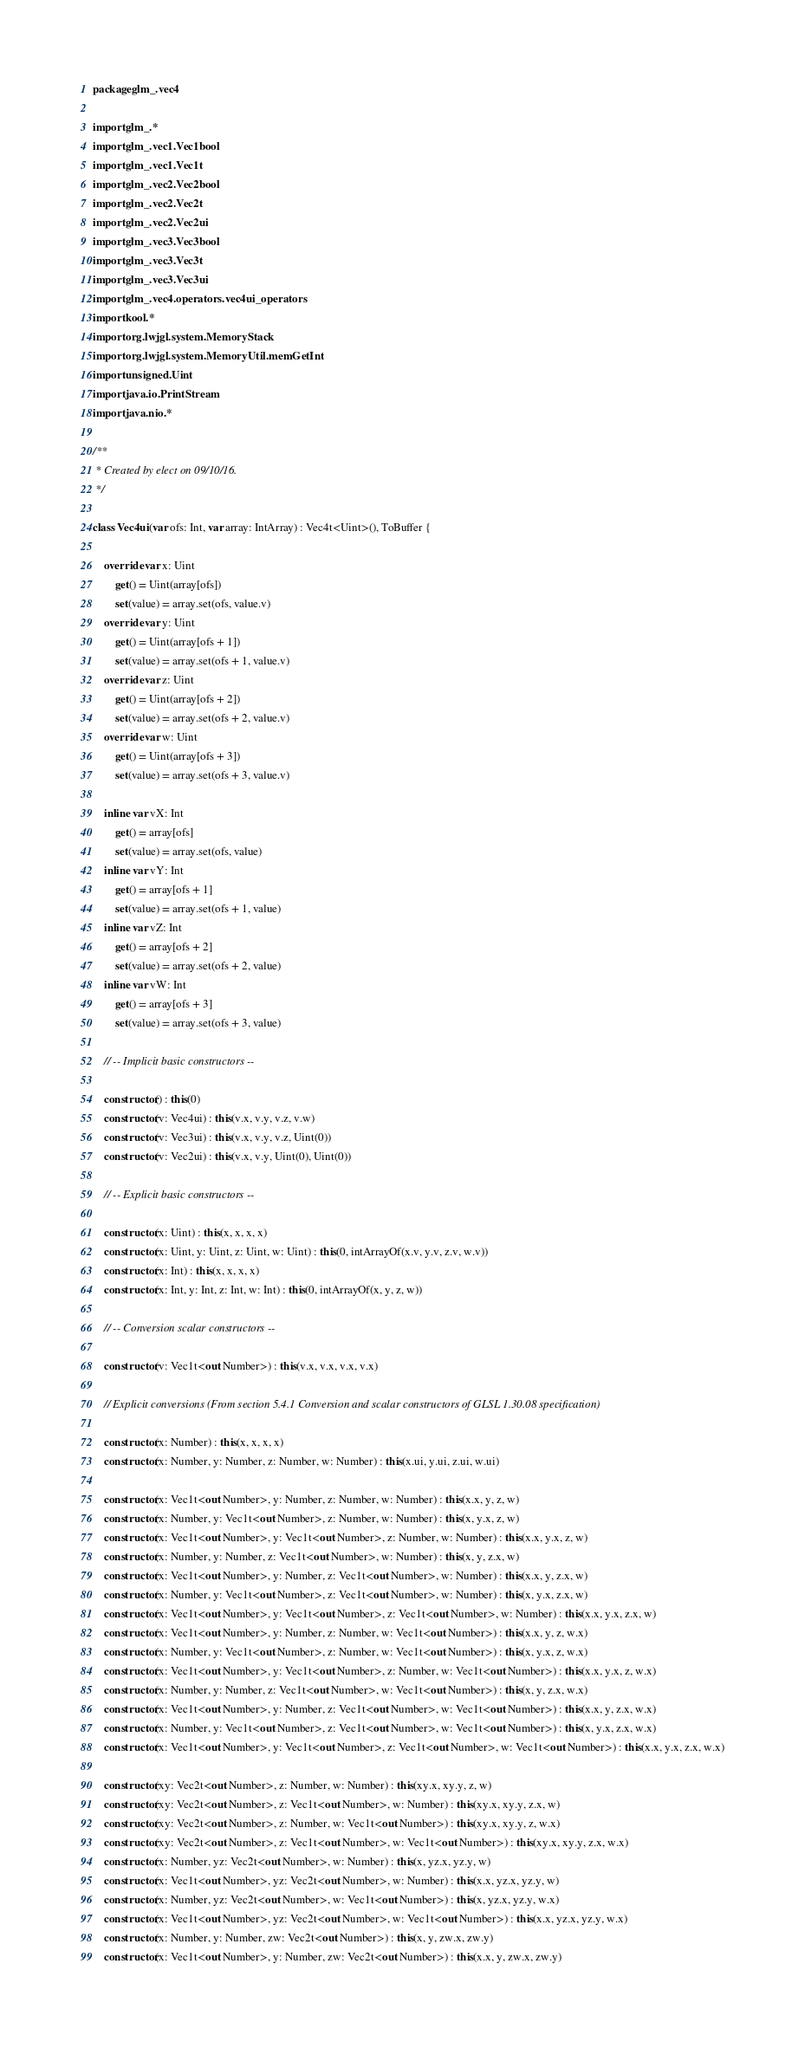Convert code to text. <code><loc_0><loc_0><loc_500><loc_500><_Kotlin_>package glm_.vec4

import glm_.*
import glm_.vec1.Vec1bool
import glm_.vec1.Vec1t
import glm_.vec2.Vec2bool
import glm_.vec2.Vec2t
import glm_.vec2.Vec2ui
import glm_.vec3.Vec3bool
import glm_.vec3.Vec3t
import glm_.vec3.Vec3ui
import glm_.vec4.operators.vec4ui_operators
import kool.*
import org.lwjgl.system.MemoryStack
import org.lwjgl.system.MemoryUtil.memGetInt
import unsigned.Uint
import java.io.PrintStream
import java.nio.*

/**
 * Created by elect on 09/10/16.
 */

class Vec4ui(var ofs: Int, var array: IntArray) : Vec4t<Uint>(), ToBuffer {

    override var x: Uint
        get() = Uint(array[ofs])
        set(value) = array.set(ofs, value.v)
    override var y: Uint
        get() = Uint(array[ofs + 1])
        set(value) = array.set(ofs + 1, value.v)
    override var z: Uint
        get() = Uint(array[ofs + 2])
        set(value) = array.set(ofs + 2, value.v)
    override var w: Uint
        get() = Uint(array[ofs + 3])
        set(value) = array.set(ofs + 3, value.v)

    inline var vX: Int
        get() = array[ofs]
        set(value) = array.set(ofs, value)
    inline var vY: Int
        get() = array[ofs + 1]
        set(value) = array.set(ofs + 1, value)
    inline var vZ: Int
        get() = array[ofs + 2]
        set(value) = array.set(ofs + 2, value)
    inline var vW: Int
        get() = array[ofs + 3]
        set(value) = array.set(ofs + 3, value)

    // -- Implicit basic constructors --

    constructor() : this(0)
    constructor(v: Vec4ui) : this(v.x, v.y, v.z, v.w)
    constructor(v: Vec3ui) : this(v.x, v.y, v.z, Uint(0))
    constructor(v: Vec2ui) : this(v.x, v.y, Uint(0), Uint(0))

    // -- Explicit basic constructors --

    constructor(x: Uint) : this(x, x, x, x)
    constructor(x: Uint, y: Uint, z: Uint, w: Uint) : this(0, intArrayOf(x.v, y.v, z.v, w.v))
    constructor(x: Int) : this(x, x, x, x)
    constructor(x: Int, y: Int, z: Int, w: Int) : this(0, intArrayOf(x, y, z, w))

    // -- Conversion scalar constructors --

    constructor(v: Vec1t<out Number>) : this(v.x, v.x, v.x, v.x)

    // Explicit conversions (From section 5.4.1 Conversion and scalar constructors of GLSL 1.30.08 specification)

    constructor(x: Number) : this(x, x, x, x)
    constructor(x: Number, y: Number, z: Number, w: Number) : this(x.ui, y.ui, z.ui, w.ui)

    constructor(x: Vec1t<out Number>, y: Number, z: Number, w: Number) : this(x.x, y, z, w)
    constructor(x: Number, y: Vec1t<out Number>, z: Number, w: Number) : this(x, y.x, z, w)
    constructor(x: Vec1t<out Number>, y: Vec1t<out Number>, z: Number, w: Number) : this(x.x, y.x, z, w)
    constructor(x: Number, y: Number, z: Vec1t<out Number>, w: Number) : this(x, y, z.x, w)
    constructor(x: Vec1t<out Number>, y: Number, z: Vec1t<out Number>, w: Number) : this(x.x, y, z.x, w)
    constructor(x: Number, y: Vec1t<out Number>, z: Vec1t<out Number>, w: Number) : this(x, y.x, z.x, w)
    constructor(x: Vec1t<out Number>, y: Vec1t<out Number>, z: Vec1t<out Number>, w: Number) : this(x.x, y.x, z.x, w)
    constructor(x: Vec1t<out Number>, y: Number, z: Number, w: Vec1t<out Number>) : this(x.x, y, z, w.x)
    constructor(x: Number, y: Vec1t<out Number>, z: Number, w: Vec1t<out Number>) : this(x, y.x, z, w.x)
    constructor(x: Vec1t<out Number>, y: Vec1t<out Number>, z: Number, w: Vec1t<out Number>) : this(x.x, y.x, z, w.x)
    constructor(x: Number, y: Number, z: Vec1t<out Number>, w: Vec1t<out Number>) : this(x, y, z.x, w.x)
    constructor(x: Vec1t<out Number>, y: Number, z: Vec1t<out Number>, w: Vec1t<out Number>) : this(x.x, y, z.x, w.x)
    constructor(x: Number, y: Vec1t<out Number>, z: Vec1t<out Number>, w: Vec1t<out Number>) : this(x, y.x, z.x, w.x)
    constructor(x: Vec1t<out Number>, y: Vec1t<out Number>, z: Vec1t<out Number>, w: Vec1t<out Number>) : this(x.x, y.x, z.x, w.x)

    constructor(xy: Vec2t<out Number>, z: Number, w: Number) : this(xy.x, xy.y, z, w)
    constructor(xy: Vec2t<out Number>, z: Vec1t<out Number>, w: Number) : this(xy.x, xy.y, z.x, w)
    constructor(xy: Vec2t<out Number>, z: Number, w: Vec1t<out Number>) : this(xy.x, xy.y, z, w.x)
    constructor(xy: Vec2t<out Number>, z: Vec1t<out Number>, w: Vec1t<out Number>) : this(xy.x, xy.y, z.x, w.x)
    constructor(x: Number, yz: Vec2t<out Number>, w: Number) : this(x, yz.x, yz.y, w)
    constructor(x: Vec1t<out Number>, yz: Vec2t<out Number>, w: Number) : this(x.x, yz.x, yz.y, w)
    constructor(x: Number, yz: Vec2t<out Number>, w: Vec1t<out Number>) : this(x, yz.x, yz.y, w.x)
    constructor(x: Vec1t<out Number>, yz: Vec2t<out Number>, w: Vec1t<out Number>) : this(x.x, yz.x, yz.y, w.x)
    constructor(x: Number, y: Number, zw: Vec2t<out Number>) : this(x, y, zw.x, zw.y)
    constructor(x: Vec1t<out Number>, y: Number, zw: Vec2t<out Number>) : this(x.x, y, zw.x, zw.y)</code> 